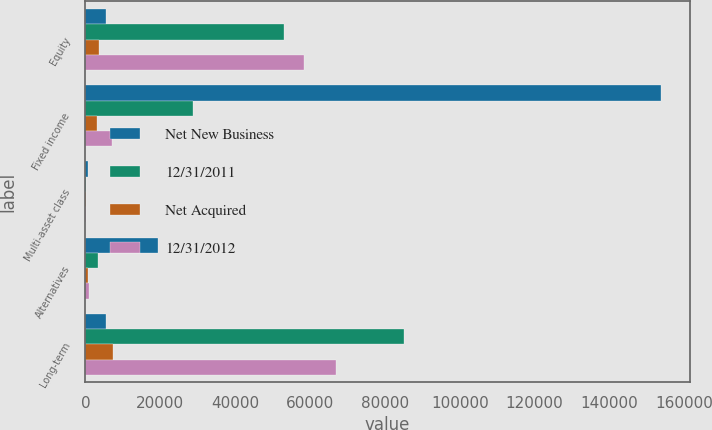<chart> <loc_0><loc_0><loc_500><loc_500><stacked_bar_chart><ecel><fcel>Equity<fcel>Fixed income<fcel>Multi-asset class<fcel>Alternatives<fcel>Long-term<nl><fcel>Net New Business<fcel>5378<fcel>153802<fcel>562<fcel>19341<fcel>5378<nl><fcel>12/31/2011<fcel>52973<fcel>28785<fcel>178<fcel>3232<fcel>85168<nl><fcel>Net Acquired<fcel>3517<fcel>3026<fcel>78<fcel>701<fcel>7322<nl><fcel>12/31/2012<fcel>58507<fcel>7239<fcel>51<fcel>1064<fcel>66861<nl></chart> 